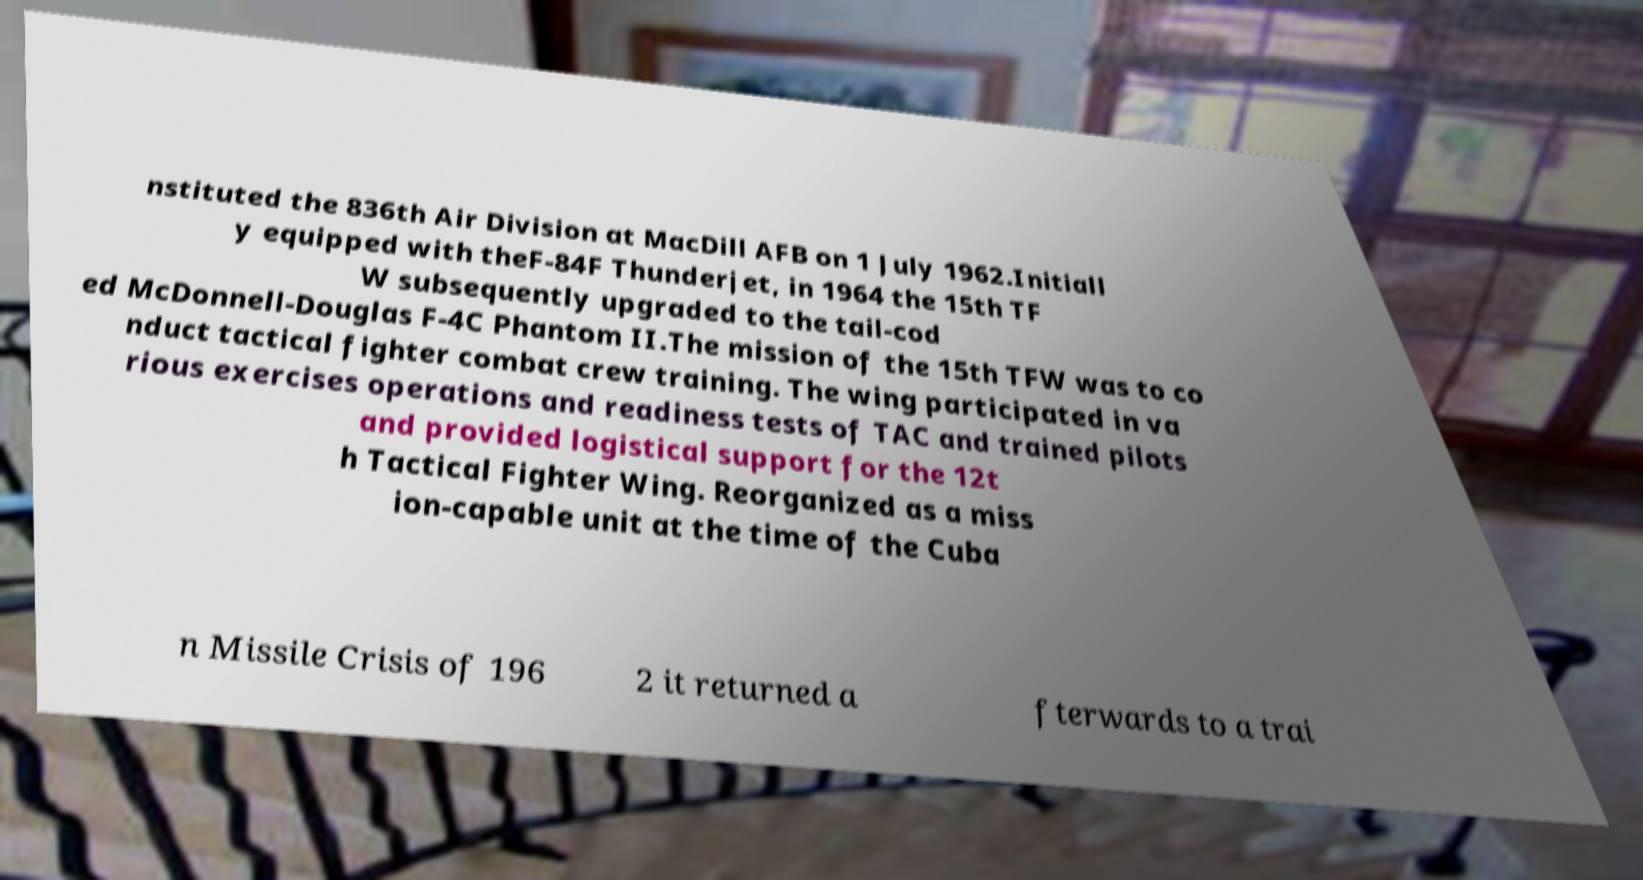Can you accurately transcribe the text from the provided image for me? nstituted the 836th Air Division at MacDill AFB on 1 July 1962.Initiall y equipped with theF-84F Thunderjet, in 1964 the 15th TF W subsequently upgraded to the tail-cod ed McDonnell-Douglas F-4C Phantom II.The mission of the 15th TFW was to co nduct tactical fighter combat crew training. The wing participated in va rious exercises operations and readiness tests of TAC and trained pilots and provided logistical support for the 12t h Tactical Fighter Wing. Reorganized as a miss ion-capable unit at the time of the Cuba n Missile Crisis of 196 2 it returned a fterwards to a trai 